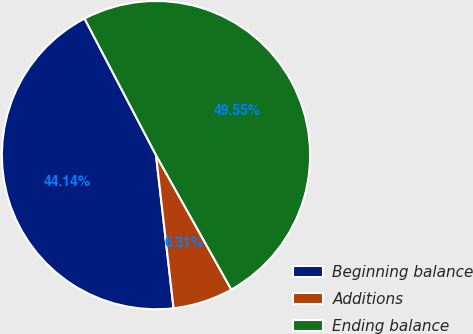Convert chart to OTSL. <chart><loc_0><loc_0><loc_500><loc_500><pie_chart><fcel>Beginning balance<fcel>Additions<fcel>Ending balance<nl><fcel>44.14%<fcel>6.31%<fcel>49.55%<nl></chart> 